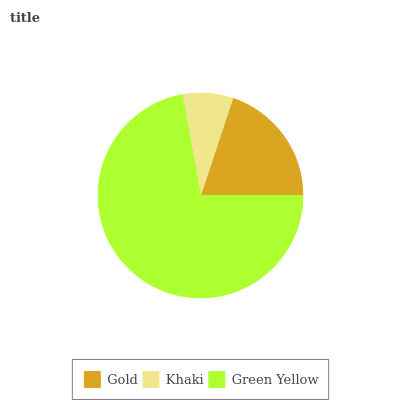Is Khaki the minimum?
Answer yes or no. Yes. Is Green Yellow the maximum?
Answer yes or no. Yes. Is Green Yellow the minimum?
Answer yes or no. No. Is Khaki the maximum?
Answer yes or no. No. Is Green Yellow greater than Khaki?
Answer yes or no. Yes. Is Khaki less than Green Yellow?
Answer yes or no. Yes. Is Khaki greater than Green Yellow?
Answer yes or no. No. Is Green Yellow less than Khaki?
Answer yes or no. No. Is Gold the high median?
Answer yes or no. Yes. Is Gold the low median?
Answer yes or no. Yes. Is Green Yellow the high median?
Answer yes or no. No. Is Green Yellow the low median?
Answer yes or no. No. 